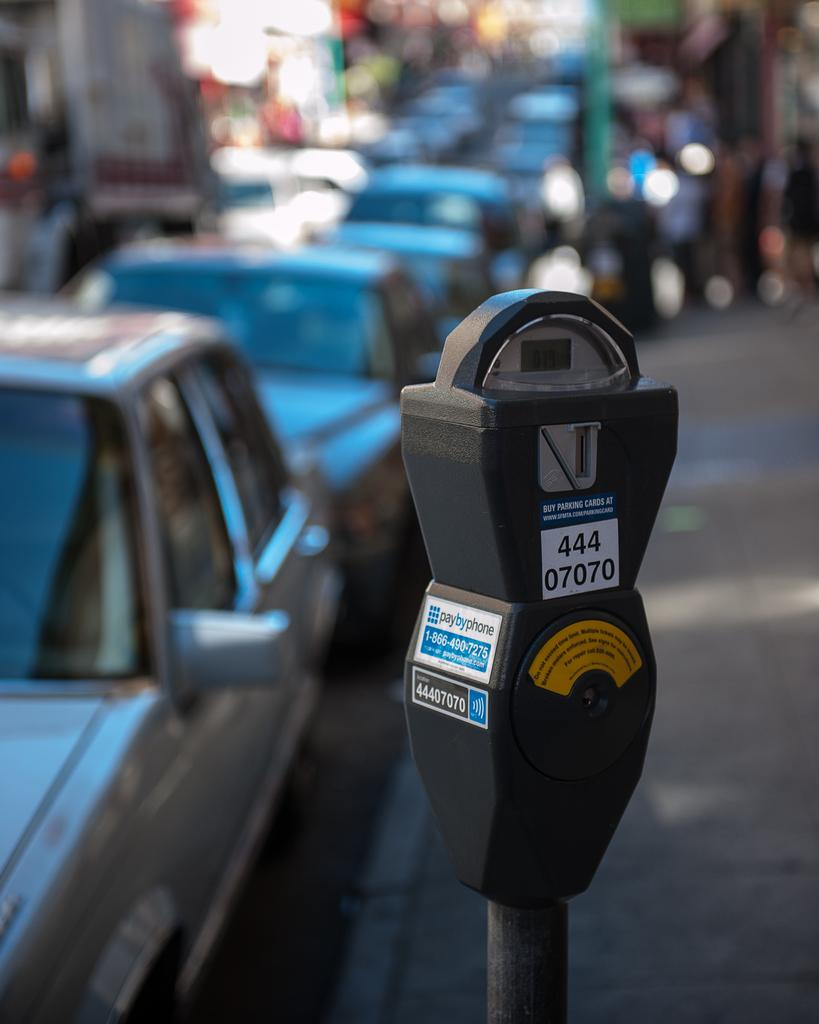<image>
Present a compact description of the photo's key features. A pay by phone parking meter number 444 07070. 